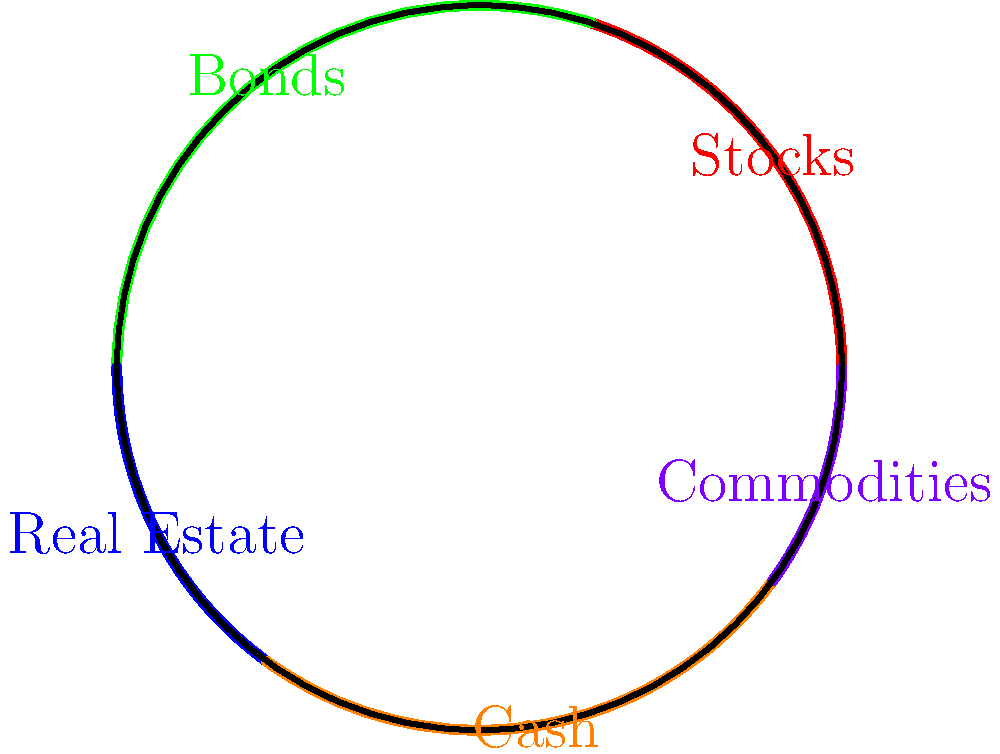In the polar graph representing an investment portfolio's asset allocation, which asset class has the largest allocation, and what is its percentage? To determine the asset class with the largest allocation and its percentage, we need to analyze the polar graph:

1. The graph shows five asset classes: Stocks, Bonds, Real Estate, Cash, and Commodities.
2. Each asset class is represented by a colored arc on the circle.
3. The size of each arc corresponds to the percentage allocation of that asset class.
4. To find the largest allocation, we need to identify the largest arc:

   - Stocks (red): Approximately 20%
   - Bonds (green): Approximately 30%
   - Real Estate (blue): Approximately 15%
   - Cash (orange): Approximately 25%
   - Commodities (purple): Approximately 10%

5. The largest arc is green, which represents Bonds.
6. The Bonds arc covers approximately 30% of the circle.

Therefore, Bonds have the largest allocation at 30%.
Answer: Bonds, 30% 